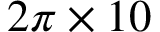Convert formula to latex. <formula><loc_0><loc_0><loc_500><loc_500>2 \pi \times 1 0</formula> 